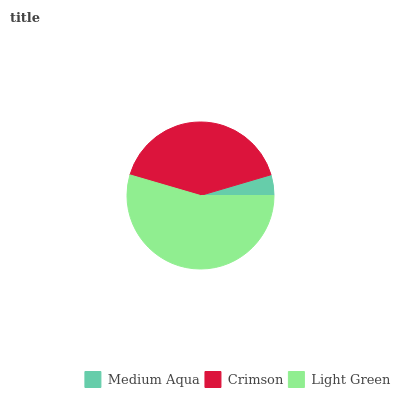Is Medium Aqua the minimum?
Answer yes or no. Yes. Is Light Green the maximum?
Answer yes or no. Yes. Is Crimson the minimum?
Answer yes or no. No. Is Crimson the maximum?
Answer yes or no. No. Is Crimson greater than Medium Aqua?
Answer yes or no. Yes. Is Medium Aqua less than Crimson?
Answer yes or no. Yes. Is Medium Aqua greater than Crimson?
Answer yes or no. No. Is Crimson less than Medium Aqua?
Answer yes or no. No. Is Crimson the high median?
Answer yes or no. Yes. Is Crimson the low median?
Answer yes or no. Yes. Is Medium Aqua the high median?
Answer yes or no. No. Is Light Green the low median?
Answer yes or no. No. 